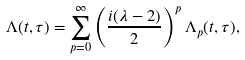Convert formula to latex. <formula><loc_0><loc_0><loc_500><loc_500>\Lambda ( t , \tau ) = \sum _ { p = 0 } ^ { \infty } \left ( \frac { i ( \lambda - 2 ) } { 2 } \right ) ^ { p } \Lambda _ { p } ( t , \tau ) ,</formula> 